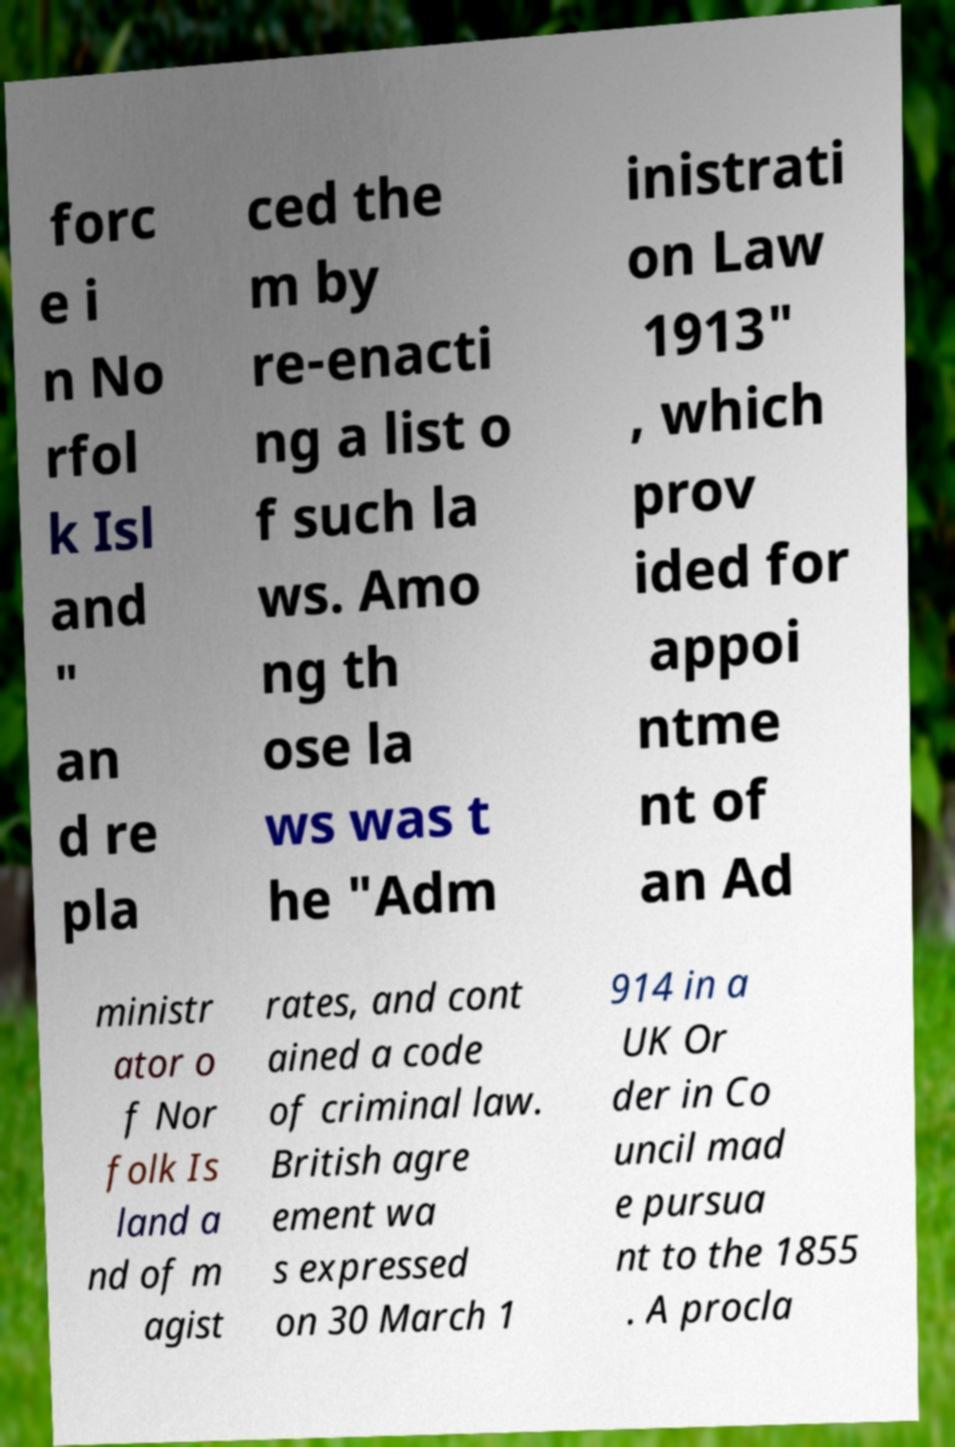For documentation purposes, I need the text within this image transcribed. Could you provide that? forc e i n No rfol k Isl and " an d re pla ced the m by re-enacti ng a list o f such la ws. Amo ng th ose la ws was t he "Adm inistrati on Law 1913" , which prov ided for appoi ntme nt of an Ad ministr ator o f Nor folk Is land a nd of m agist rates, and cont ained a code of criminal law. British agre ement wa s expressed on 30 March 1 914 in a UK Or der in Co uncil mad e pursua nt to the 1855 . A procla 